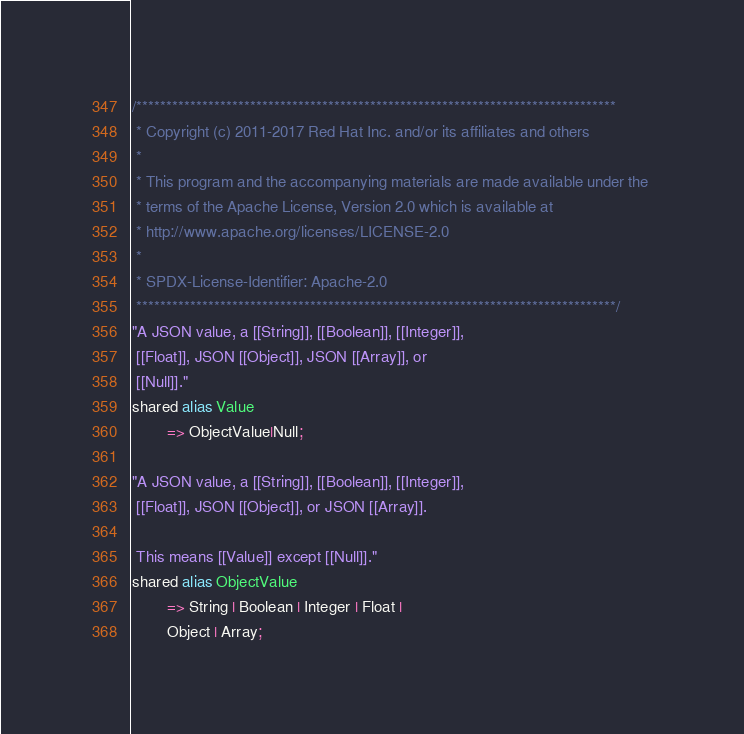<code> <loc_0><loc_0><loc_500><loc_500><_Ceylon_>/********************************************************************************
 * Copyright (c) 2011-2017 Red Hat Inc. and/or its affiliates and others
 *
 * This program and the accompanying materials are made available under the 
 * terms of the Apache License, Version 2.0 which is available at
 * http://www.apache.org/licenses/LICENSE-2.0
 *
 * SPDX-License-Identifier: Apache-2.0 
 ********************************************************************************/
"A JSON value, a [[String]], [[Boolean]], [[Integer]],
 [[Float]], JSON [[Object]], JSON [[Array]], or 
 [[Null]]."
shared alias Value 
        => ObjectValue|Null;

"A JSON value, a [[String]], [[Boolean]], [[Integer]],
 [[Float]], JSON [[Object]], or JSON [[Array]].
 
 This means [[Value]] except [[Null]]."
shared alias ObjectValue
		=> String | Boolean | Integer | Float |
		Object | Array;</code> 